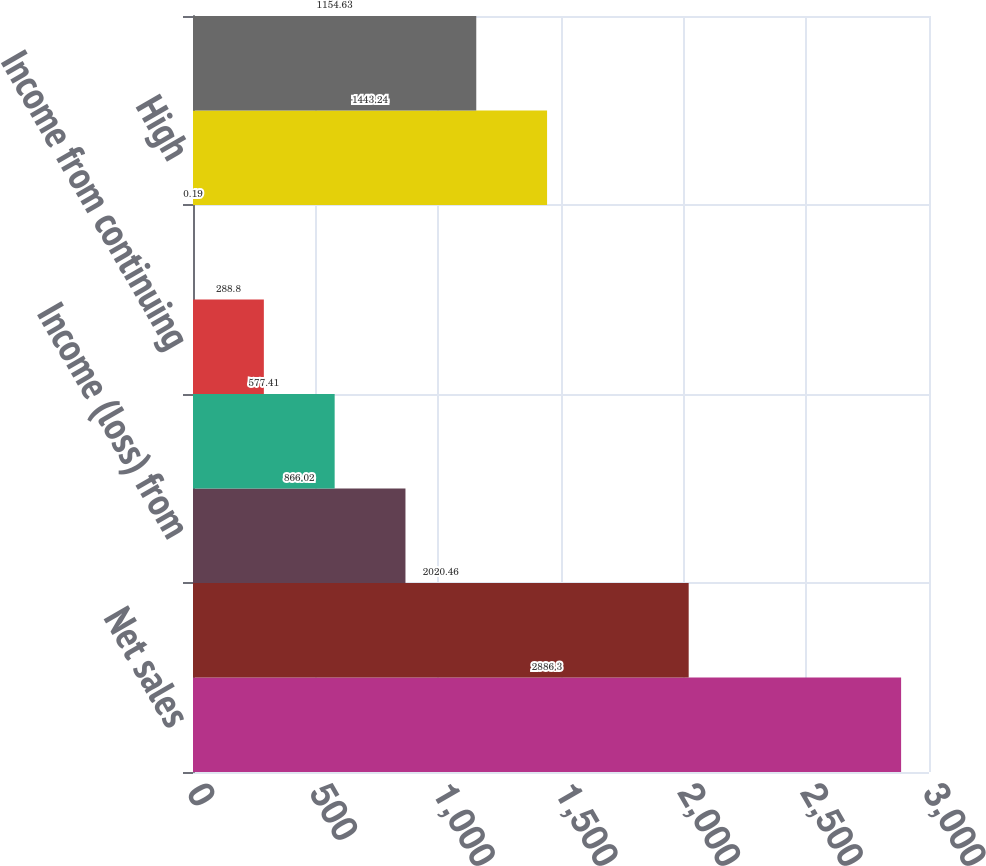Convert chart. <chart><loc_0><loc_0><loc_500><loc_500><bar_chart><fcel>Net sales<fcel>Gross profit<fcel>Income (loss) from<fcel>Net income attributable to<fcel>Income from continuing<fcel>Dividends declared per common<fcel>High<fcel>Low<nl><fcel>2886.3<fcel>2020.46<fcel>866.02<fcel>577.41<fcel>288.8<fcel>0.19<fcel>1443.24<fcel>1154.63<nl></chart> 